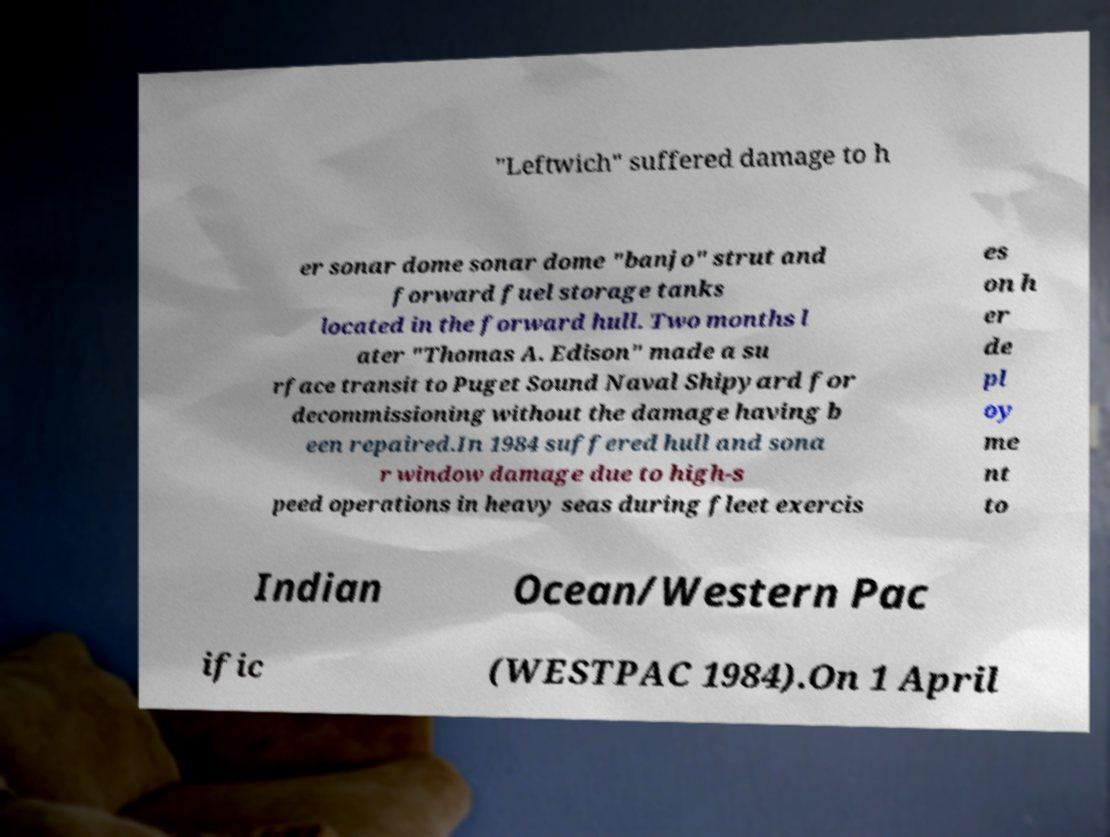I need the written content from this picture converted into text. Can you do that? "Leftwich" suffered damage to h er sonar dome sonar dome "banjo" strut and forward fuel storage tanks located in the forward hull. Two months l ater "Thomas A. Edison" made a su rface transit to Puget Sound Naval Shipyard for decommissioning without the damage having b een repaired.In 1984 suffered hull and sona r window damage due to high-s peed operations in heavy seas during fleet exercis es on h er de pl oy me nt to Indian Ocean/Western Pac ific (WESTPAC 1984).On 1 April 